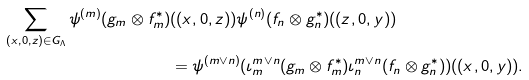Convert formula to latex. <formula><loc_0><loc_0><loc_500><loc_500>\sum _ { ( x , 0 , z ) \in G _ { \Lambda } } \psi ^ { ( m ) } ( g _ { m } \otimes f _ { m } ^ { * } ) & ( ( x , 0 , z ) ) \psi ^ { ( n ) } ( f _ { n } \otimes g _ { n } ^ { * } ) ( ( z , 0 , y ) ) \\ & = \psi ^ { ( m \vee n ) } ( \iota _ { m } ^ { m \vee n } ( g _ { m } \otimes f _ { m } ^ { * } ) \iota _ { n } ^ { m \vee n } ( f _ { n } \otimes g _ { n } ^ { * } ) ) ( ( x , 0 , y ) ) .</formula> 